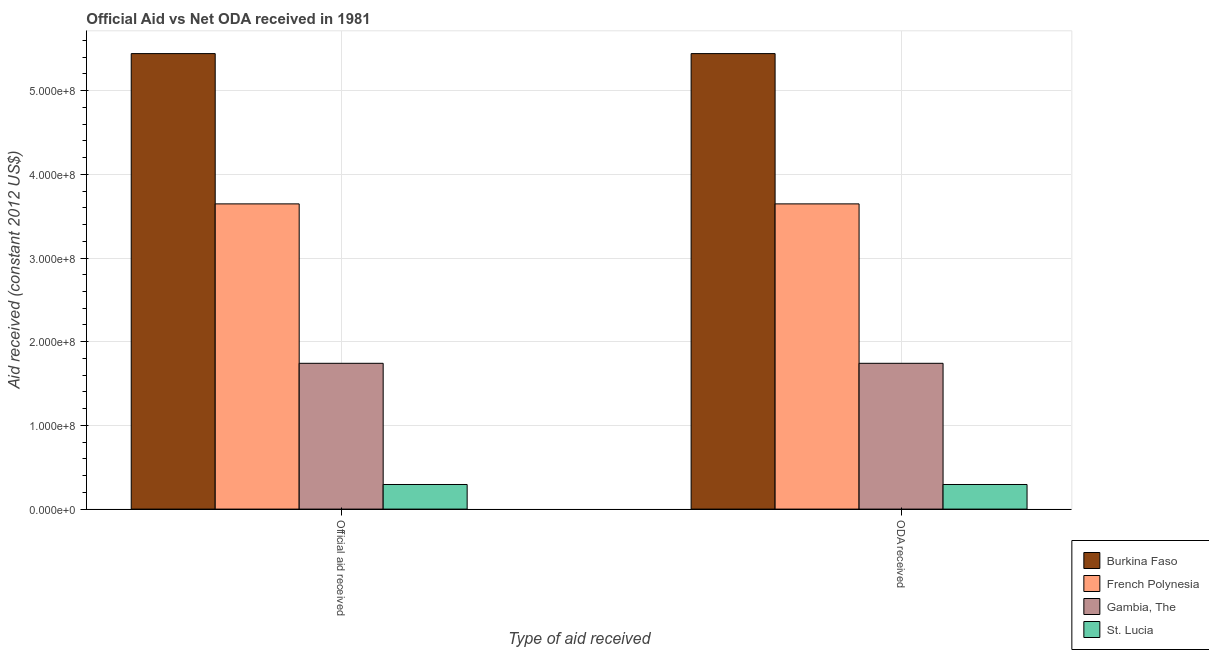Are the number of bars on each tick of the X-axis equal?
Keep it short and to the point. Yes. What is the label of the 2nd group of bars from the left?
Ensure brevity in your answer.  ODA received. What is the oda received in Gambia, The?
Your answer should be compact. 1.74e+08. Across all countries, what is the maximum oda received?
Keep it short and to the point. 5.44e+08. Across all countries, what is the minimum oda received?
Your answer should be very brief. 2.94e+07. In which country was the oda received maximum?
Give a very brief answer. Burkina Faso. In which country was the oda received minimum?
Make the answer very short. St. Lucia. What is the total oda received in the graph?
Give a very brief answer. 1.11e+09. What is the difference between the official aid received in St. Lucia and that in Gambia, The?
Ensure brevity in your answer.  -1.45e+08. What is the difference between the oda received in St. Lucia and the official aid received in French Polynesia?
Keep it short and to the point. -3.35e+08. What is the average official aid received per country?
Offer a very short reply. 2.78e+08. What is the ratio of the oda received in Burkina Faso to that in Gambia, The?
Your answer should be very brief. 3.12. In how many countries, is the oda received greater than the average oda received taken over all countries?
Provide a short and direct response. 2. What does the 1st bar from the left in Official aid received represents?
Offer a terse response. Burkina Faso. What does the 4th bar from the right in ODA received represents?
Ensure brevity in your answer.  Burkina Faso. How many bars are there?
Make the answer very short. 8. Are all the bars in the graph horizontal?
Your answer should be very brief. No. How many countries are there in the graph?
Provide a succinct answer. 4. Are the values on the major ticks of Y-axis written in scientific E-notation?
Your response must be concise. Yes. Does the graph contain grids?
Provide a short and direct response. Yes. Where does the legend appear in the graph?
Keep it short and to the point. Bottom right. How many legend labels are there?
Keep it short and to the point. 4. How are the legend labels stacked?
Keep it short and to the point. Vertical. What is the title of the graph?
Keep it short and to the point. Official Aid vs Net ODA received in 1981 . What is the label or title of the X-axis?
Provide a short and direct response. Type of aid received. What is the label or title of the Y-axis?
Provide a succinct answer. Aid received (constant 2012 US$). What is the Aid received (constant 2012 US$) of Burkina Faso in Official aid received?
Make the answer very short. 5.44e+08. What is the Aid received (constant 2012 US$) of French Polynesia in Official aid received?
Keep it short and to the point. 3.65e+08. What is the Aid received (constant 2012 US$) in Gambia, The in Official aid received?
Provide a short and direct response. 1.74e+08. What is the Aid received (constant 2012 US$) in St. Lucia in Official aid received?
Your answer should be very brief. 2.94e+07. What is the Aid received (constant 2012 US$) of Burkina Faso in ODA received?
Provide a short and direct response. 5.44e+08. What is the Aid received (constant 2012 US$) of French Polynesia in ODA received?
Provide a succinct answer. 3.65e+08. What is the Aid received (constant 2012 US$) of Gambia, The in ODA received?
Your response must be concise. 1.74e+08. What is the Aid received (constant 2012 US$) in St. Lucia in ODA received?
Offer a very short reply. 2.94e+07. Across all Type of aid received, what is the maximum Aid received (constant 2012 US$) of Burkina Faso?
Offer a very short reply. 5.44e+08. Across all Type of aid received, what is the maximum Aid received (constant 2012 US$) in French Polynesia?
Offer a very short reply. 3.65e+08. Across all Type of aid received, what is the maximum Aid received (constant 2012 US$) in Gambia, The?
Provide a short and direct response. 1.74e+08. Across all Type of aid received, what is the maximum Aid received (constant 2012 US$) of St. Lucia?
Provide a short and direct response. 2.94e+07. Across all Type of aid received, what is the minimum Aid received (constant 2012 US$) in Burkina Faso?
Provide a short and direct response. 5.44e+08. Across all Type of aid received, what is the minimum Aid received (constant 2012 US$) of French Polynesia?
Offer a very short reply. 3.65e+08. Across all Type of aid received, what is the minimum Aid received (constant 2012 US$) in Gambia, The?
Provide a succinct answer. 1.74e+08. Across all Type of aid received, what is the minimum Aid received (constant 2012 US$) of St. Lucia?
Offer a terse response. 2.94e+07. What is the total Aid received (constant 2012 US$) of Burkina Faso in the graph?
Your answer should be very brief. 1.09e+09. What is the total Aid received (constant 2012 US$) in French Polynesia in the graph?
Make the answer very short. 7.29e+08. What is the total Aid received (constant 2012 US$) of Gambia, The in the graph?
Ensure brevity in your answer.  3.48e+08. What is the total Aid received (constant 2012 US$) in St. Lucia in the graph?
Provide a short and direct response. 5.88e+07. What is the difference between the Aid received (constant 2012 US$) of Burkina Faso in Official aid received and that in ODA received?
Ensure brevity in your answer.  0. What is the difference between the Aid received (constant 2012 US$) in St. Lucia in Official aid received and that in ODA received?
Provide a succinct answer. 0. What is the difference between the Aid received (constant 2012 US$) in Burkina Faso in Official aid received and the Aid received (constant 2012 US$) in French Polynesia in ODA received?
Offer a very short reply. 1.80e+08. What is the difference between the Aid received (constant 2012 US$) in Burkina Faso in Official aid received and the Aid received (constant 2012 US$) in Gambia, The in ODA received?
Offer a very short reply. 3.70e+08. What is the difference between the Aid received (constant 2012 US$) in Burkina Faso in Official aid received and the Aid received (constant 2012 US$) in St. Lucia in ODA received?
Offer a very short reply. 5.15e+08. What is the difference between the Aid received (constant 2012 US$) of French Polynesia in Official aid received and the Aid received (constant 2012 US$) of Gambia, The in ODA received?
Your answer should be compact. 1.90e+08. What is the difference between the Aid received (constant 2012 US$) of French Polynesia in Official aid received and the Aid received (constant 2012 US$) of St. Lucia in ODA received?
Your response must be concise. 3.35e+08. What is the difference between the Aid received (constant 2012 US$) of Gambia, The in Official aid received and the Aid received (constant 2012 US$) of St. Lucia in ODA received?
Your answer should be very brief. 1.45e+08. What is the average Aid received (constant 2012 US$) in Burkina Faso per Type of aid received?
Ensure brevity in your answer.  5.44e+08. What is the average Aid received (constant 2012 US$) of French Polynesia per Type of aid received?
Keep it short and to the point. 3.65e+08. What is the average Aid received (constant 2012 US$) of Gambia, The per Type of aid received?
Offer a terse response. 1.74e+08. What is the average Aid received (constant 2012 US$) of St. Lucia per Type of aid received?
Offer a terse response. 2.94e+07. What is the difference between the Aid received (constant 2012 US$) of Burkina Faso and Aid received (constant 2012 US$) of French Polynesia in Official aid received?
Make the answer very short. 1.80e+08. What is the difference between the Aid received (constant 2012 US$) in Burkina Faso and Aid received (constant 2012 US$) in Gambia, The in Official aid received?
Provide a succinct answer. 3.70e+08. What is the difference between the Aid received (constant 2012 US$) in Burkina Faso and Aid received (constant 2012 US$) in St. Lucia in Official aid received?
Ensure brevity in your answer.  5.15e+08. What is the difference between the Aid received (constant 2012 US$) of French Polynesia and Aid received (constant 2012 US$) of Gambia, The in Official aid received?
Keep it short and to the point. 1.90e+08. What is the difference between the Aid received (constant 2012 US$) in French Polynesia and Aid received (constant 2012 US$) in St. Lucia in Official aid received?
Make the answer very short. 3.35e+08. What is the difference between the Aid received (constant 2012 US$) of Gambia, The and Aid received (constant 2012 US$) of St. Lucia in Official aid received?
Give a very brief answer. 1.45e+08. What is the difference between the Aid received (constant 2012 US$) in Burkina Faso and Aid received (constant 2012 US$) in French Polynesia in ODA received?
Provide a succinct answer. 1.80e+08. What is the difference between the Aid received (constant 2012 US$) in Burkina Faso and Aid received (constant 2012 US$) in Gambia, The in ODA received?
Make the answer very short. 3.70e+08. What is the difference between the Aid received (constant 2012 US$) in Burkina Faso and Aid received (constant 2012 US$) in St. Lucia in ODA received?
Offer a terse response. 5.15e+08. What is the difference between the Aid received (constant 2012 US$) in French Polynesia and Aid received (constant 2012 US$) in Gambia, The in ODA received?
Keep it short and to the point. 1.90e+08. What is the difference between the Aid received (constant 2012 US$) in French Polynesia and Aid received (constant 2012 US$) in St. Lucia in ODA received?
Provide a succinct answer. 3.35e+08. What is the difference between the Aid received (constant 2012 US$) in Gambia, The and Aid received (constant 2012 US$) in St. Lucia in ODA received?
Ensure brevity in your answer.  1.45e+08. What is the ratio of the Aid received (constant 2012 US$) in French Polynesia in Official aid received to that in ODA received?
Offer a very short reply. 1. What is the ratio of the Aid received (constant 2012 US$) in Gambia, The in Official aid received to that in ODA received?
Provide a short and direct response. 1. What is the ratio of the Aid received (constant 2012 US$) of St. Lucia in Official aid received to that in ODA received?
Ensure brevity in your answer.  1. What is the difference between the highest and the lowest Aid received (constant 2012 US$) of French Polynesia?
Offer a very short reply. 0. What is the difference between the highest and the lowest Aid received (constant 2012 US$) of St. Lucia?
Give a very brief answer. 0. 